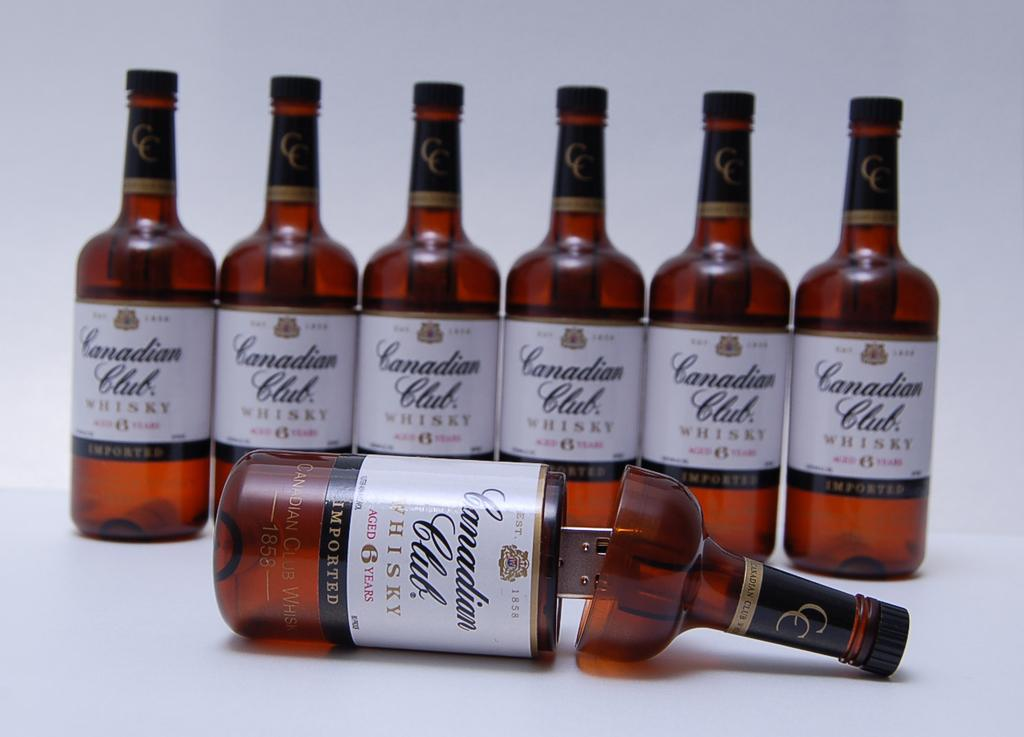<image>
Offer a succinct explanation of the picture presented. The imported whisky is from Canadian Club Whisky 